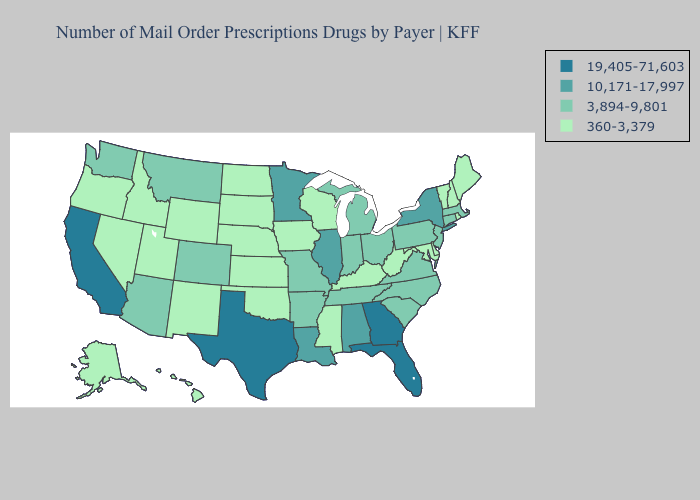Does the first symbol in the legend represent the smallest category?
Concise answer only. No. Does Minnesota have the highest value in the MidWest?
Keep it brief. Yes. What is the lowest value in the MidWest?
Answer briefly. 360-3,379. Does Pennsylvania have the highest value in the USA?
Keep it brief. No. Name the states that have a value in the range 360-3,379?
Keep it brief. Alaska, Delaware, Hawaii, Idaho, Iowa, Kansas, Kentucky, Maine, Maryland, Mississippi, Nebraska, Nevada, New Hampshire, New Mexico, North Dakota, Oklahoma, Oregon, Rhode Island, South Dakota, Utah, Vermont, West Virginia, Wisconsin, Wyoming. What is the value of Virginia?
Answer briefly. 3,894-9,801. What is the value of Nebraska?
Short answer required. 360-3,379. Does the first symbol in the legend represent the smallest category?
Concise answer only. No. Name the states that have a value in the range 360-3,379?
Give a very brief answer. Alaska, Delaware, Hawaii, Idaho, Iowa, Kansas, Kentucky, Maine, Maryland, Mississippi, Nebraska, Nevada, New Hampshire, New Mexico, North Dakota, Oklahoma, Oregon, Rhode Island, South Dakota, Utah, Vermont, West Virginia, Wisconsin, Wyoming. Does Tennessee have the highest value in the USA?
Short answer required. No. Does Illinois have the highest value in the MidWest?
Give a very brief answer. Yes. What is the lowest value in the South?
Be succinct. 360-3,379. Which states have the highest value in the USA?
Be succinct. California, Florida, Georgia, Texas. What is the value of Colorado?
Concise answer only. 3,894-9,801. What is the value of Maryland?
Short answer required. 360-3,379. 